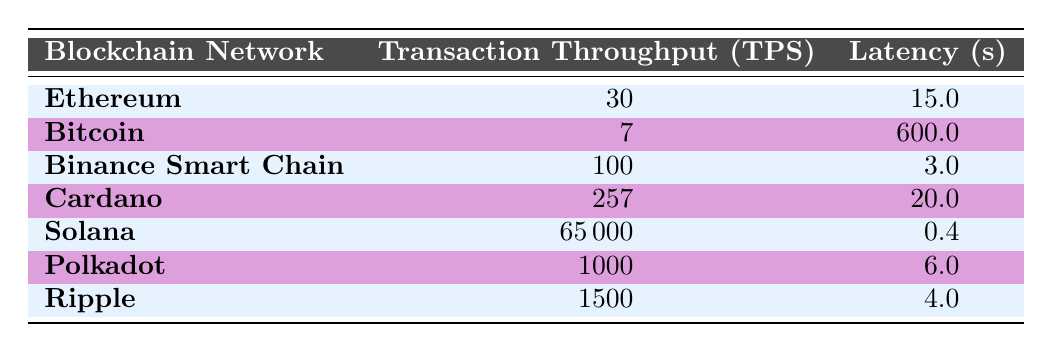What is the transaction throughput of Solana? According to the table, the transaction throughput for Solana is listed under the "Transaction Throughput (TPS)" column, where it is specifically stated as 65000 TPS.
Answer: 65000 Which blockchain has the highest latency? By examining the "Latency (s)" column, Bitcoin has the highest value recorded at 600 seconds.
Answer: Bitcoin What is the average transaction throughput of Ethereum and Cardano? To find the average, first add the throughput of Ethereum (30) and Cardano (257), which gives 287. Then, divide by 2, resulting in an average of 143.5 TPS.
Answer: 143.5 Does Ripple have a lower transaction throughput than Polkadot? Comparing the "Transaction Throughput (TPS)" values, Ripple has 1500 TPS and Polkadot has 1000 TPS. Since 1500 is greater than 1000, the statement is false.
Answer: No What is the difference in latency between Binance Smart Chain and Cardano? The latency values are 3 seconds for Binance Smart Chain and 20 seconds for Cardano. The difference is calculated as 20 - 3 = 17 seconds.
Answer: 17 Which blockchain networks have a latency of less than 5 seconds? By scanning the "Latency (s)" column, we find that both Binance Smart Chain (3 seconds) and Ripple (4 seconds) meet this criterion.
Answer: Binance Smart Chain and Ripple What is the median transaction throughput for the listed blockchains? Sorting the transaction throughput values results in this order: 7 (Bitcoin), 30 (Ethereum), 100 (Binance Smart Chain), 257 (Cardano), 65000 (Solana), 1000 (Polkadot), 1500 (Ripple). The median, being the middle value in an ordered list of 7 entries, is the fourth value: 257 TPS.
Answer: 257 Which blockchain has the highest transaction throughput and what is that value? By reviewing the "Transaction Throughput (TPS)" values, Solana has the highest at 65000 TPS.
Answer: Solana, 65000 Is it true that Cardano has a higher transaction throughput than Ethereum? Cardano's throughput is 257 TPS while Ethereum's is 30 TPS. Since 257 is greater than 30, the statement is true.
Answer: Yes 